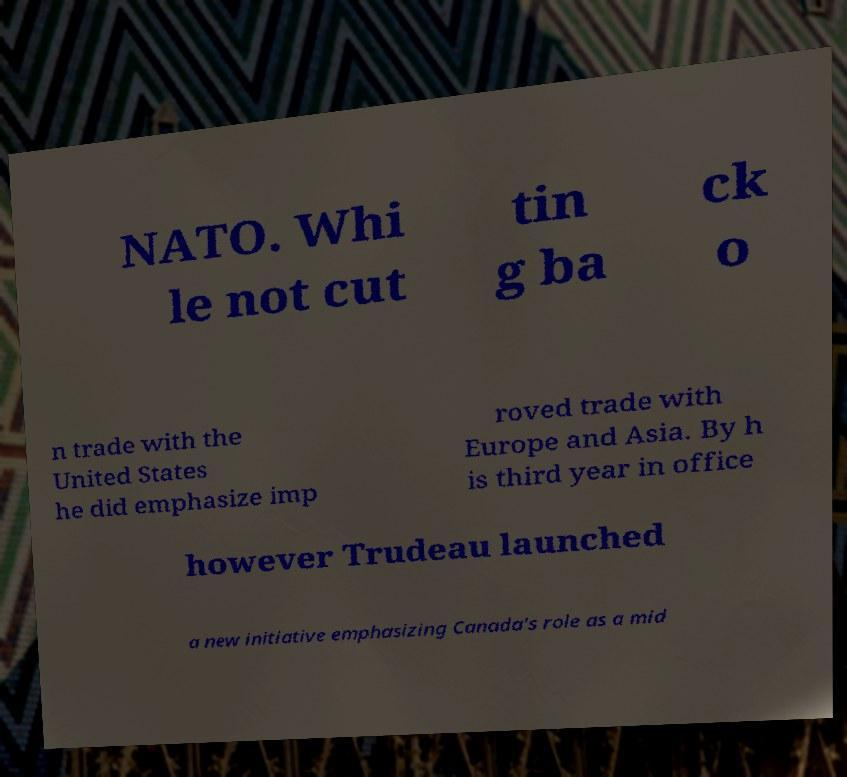What messages or text are displayed in this image? I need them in a readable, typed format. NATO. Whi le not cut tin g ba ck o n trade with the United States he did emphasize imp roved trade with Europe and Asia. By h is third year in office however Trudeau launched a new initiative emphasizing Canada's role as a mid 